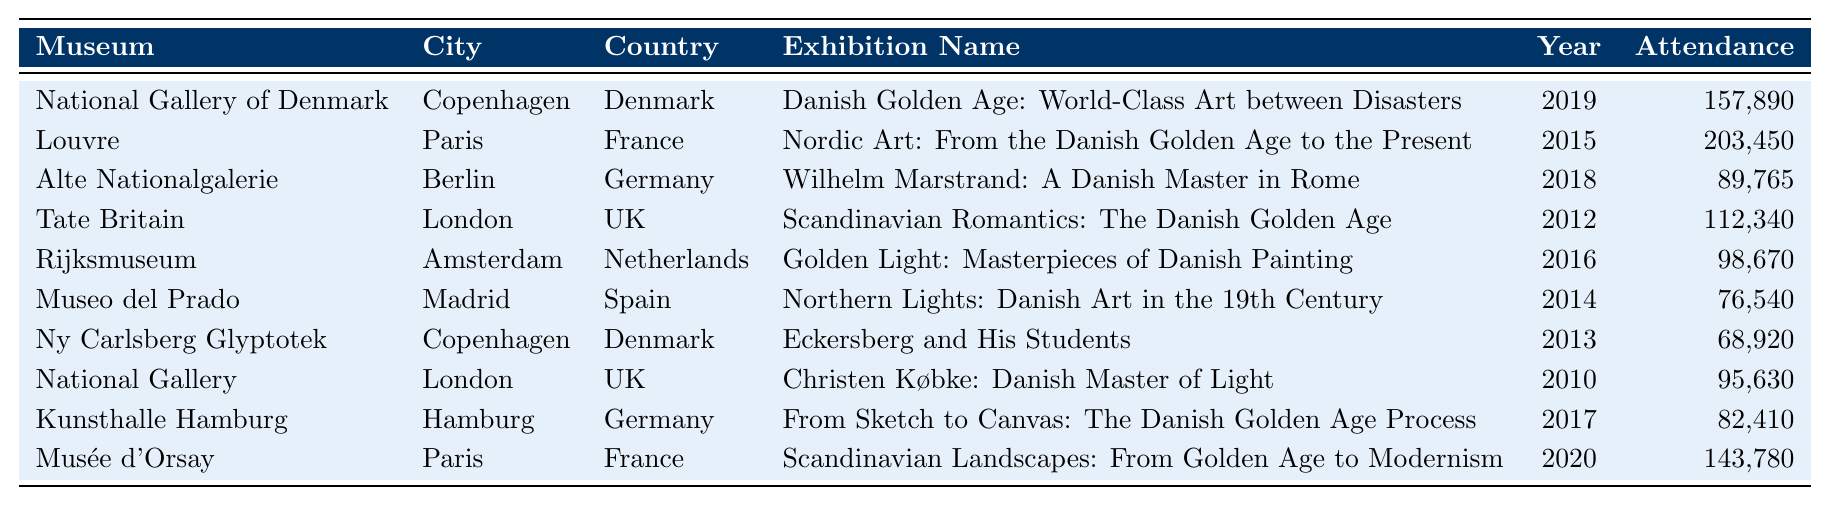What is the attendance figure for the Louvre in 2015? The Louvre's exhibition in 2015 had an attendance figure listed in the table. By checking the row corresponding to the Louvre and the year 2015, the attendance figure is 203,450.
Answer: 203,450 Which museum had the lowest attendance in the given period? To find the lowest attendance, we can compare the attendance figures in each row of the table. The lowest figure is for Museo del Prado with an attendance of 76,540.
Answer: Museo del Prado How many total visitors attended exhibitions of the Danish Golden Age across all listed museums? To calculate the total attendance, we sum up all the attendance figures from each row. This results in 157,890 + 203,450 + 89,765 + 112,340 + 98,670 + 76,540 + 68,920 + 95,630 + 82,410 + 143,780 = 1,130,055 total attendees.
Answer: 1,130,055 Which exhibition had more than 100,000 attendees? By examining the attendance figures for each exhibition, we can identify which ones exceeded 100,000. The exhibitions at the Louvre, National Gallery of Denmark, Tate Britain, and Musée d'Orsay meet this criterion.
Answer: Louvre, National Gallery of Denmark, Tate Britain, Musée d'Orsay What was the average attendance for exhibitions held in Copenhagen? First, we identify the exhibitions in Copenhagen: National Gallery of Denmark in 2019 (157,890) and Ny Carlsberg Glyptotek in 2013 (68,920). The average is (157,890 + 68,920) / 2 = 113,405.
Answer: 113,405 Did any exhibitions take place in 2014? By reviewing the table for the year 2014, we see that the exhibition at Museo del Prado titled "Northern Lights: Danish Art in the 19th Century" occurred that year. Therefore, the answer is yes.
Answer: Yes Is there any exhibition in Amsterdam? Looking at the table, we can find an entry for the Rijksmuseum located in Amsterdam with the exhibition "Golden Light: Masterpieces of Danish Painting." This confirms that there is indeed an exhibition in Amsterdam.
Answer: Yes Which city had the highest attendance for its exhibition? We compare the attendance figures from the table and find that the Louvre in Paris had the highest attendance at 203,450, surpassing all other cities' attendance.
Answer: Paris What is the difference in attendance between the exhibitions in London and Copenhagen? The exhibition attendance figures for London are from Tate Britain (112,340) and National Gallery (95,630). The total for London is 112,340 + 95,630 = 207,970. For Copenhagen, it is 157,890 + 68,920 = 226,810. The difference is 226,810 - 207,970 = 18,840.
Answer: 18,840 Which museum consistently had exhibitions from 2010 to 2020? By reviewing the given data, we detect that the National Gallery and museums in Copenhagen had exhibitions during the time frame, making them consistent among the others listed.
Answer: National Gallery, Ny Carlsberg Glyptotek What can be concluded about the Danish Golden Age exhibitions across European museums during this period? By analyzing the table, we see that attendance figures vary, with some exhibitions drawing large crowds (over 100,000) while others were less attended. Most locations hosted related exhibitions, highlighting the enduring interest in Danish Golden Age art across Europe.
Answer: Interest in Danish Golden Age art is consistent but varies in attendance 